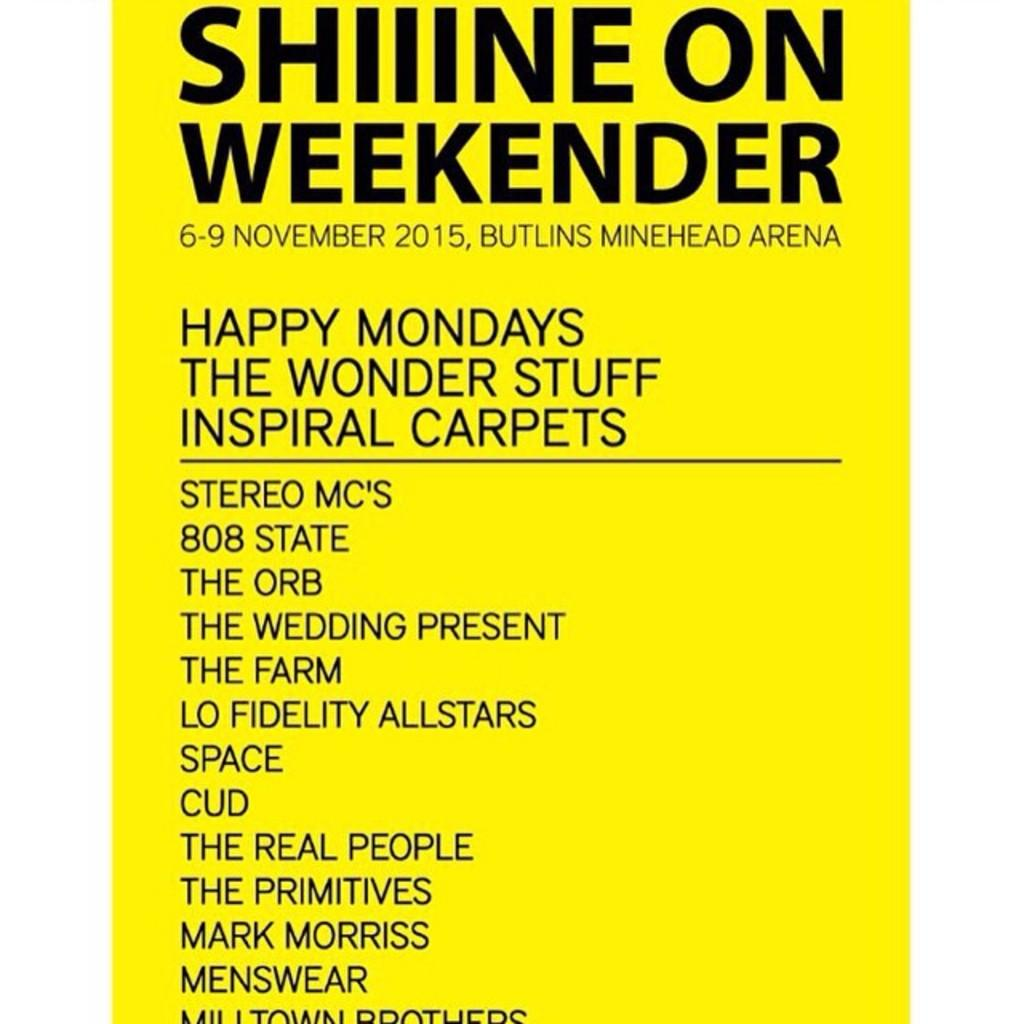<image>
Offer a succinct explanation of the picture presented. An advertisement for shiine on weekender that was from November 6-9, 2015. 